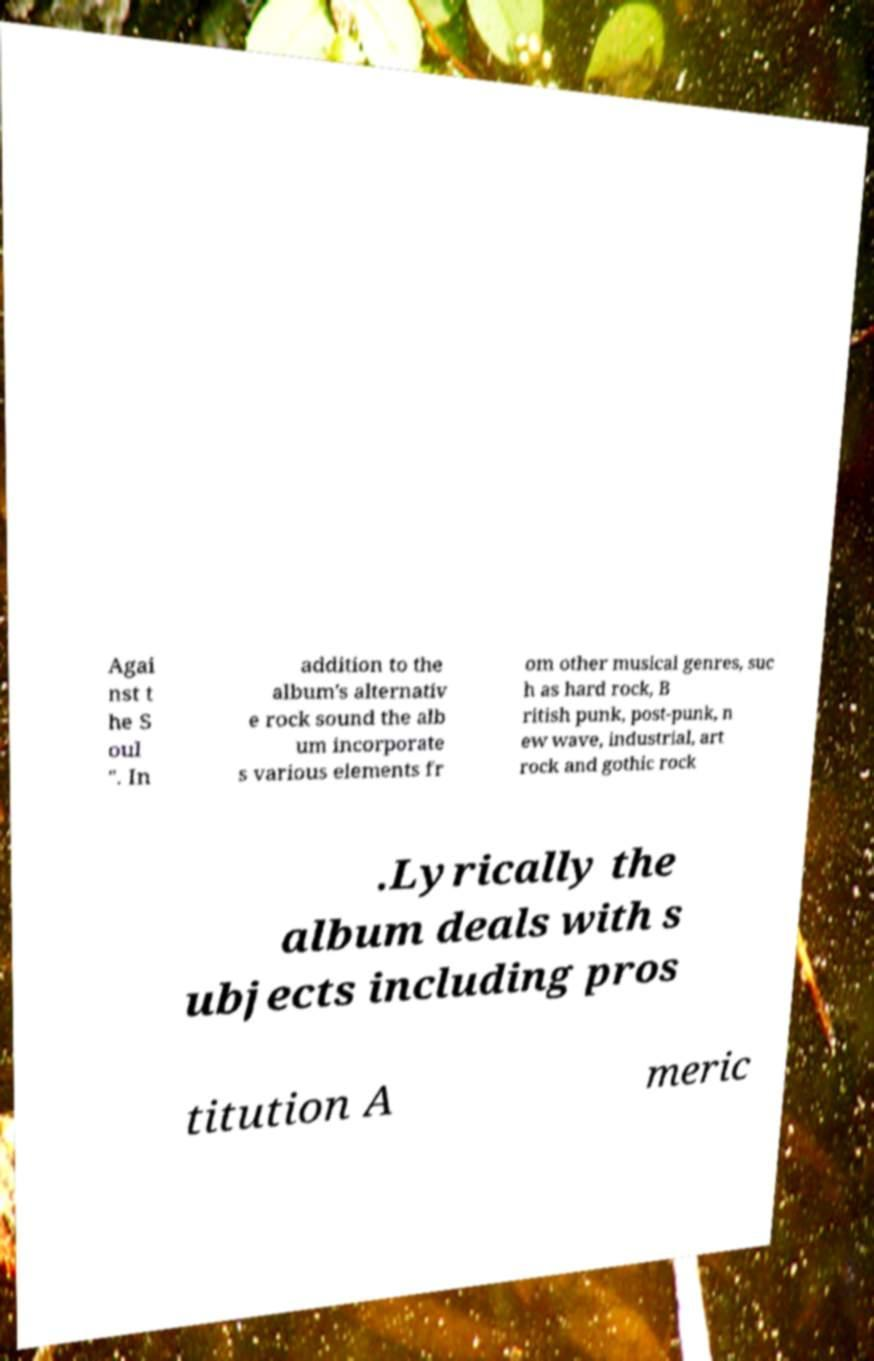There's text embedded in this image that I need extracted. Can you transcribe it verbatim? Agai nst t he S oul ". In addition to the album's alternativ e rock sound the alb um incorporate s various elements fr om other musical genres, suc h as hard rock, B ritish punk, post-punk, n ew wave, industrial, art rock and gothic rock .Lyrically the album deals with s ubjects including pros titution A meric 